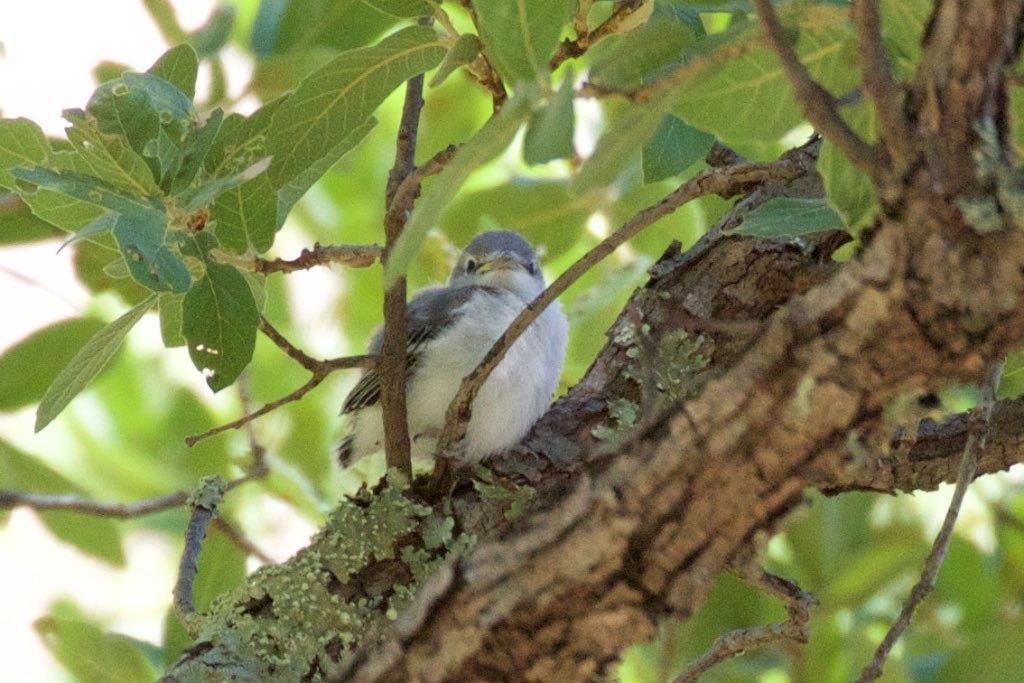Could you give a brief overview of what you see in this image? In this image in the front there is a tree trunk and there is a bird standing on the tree trunk and there are leaves. 